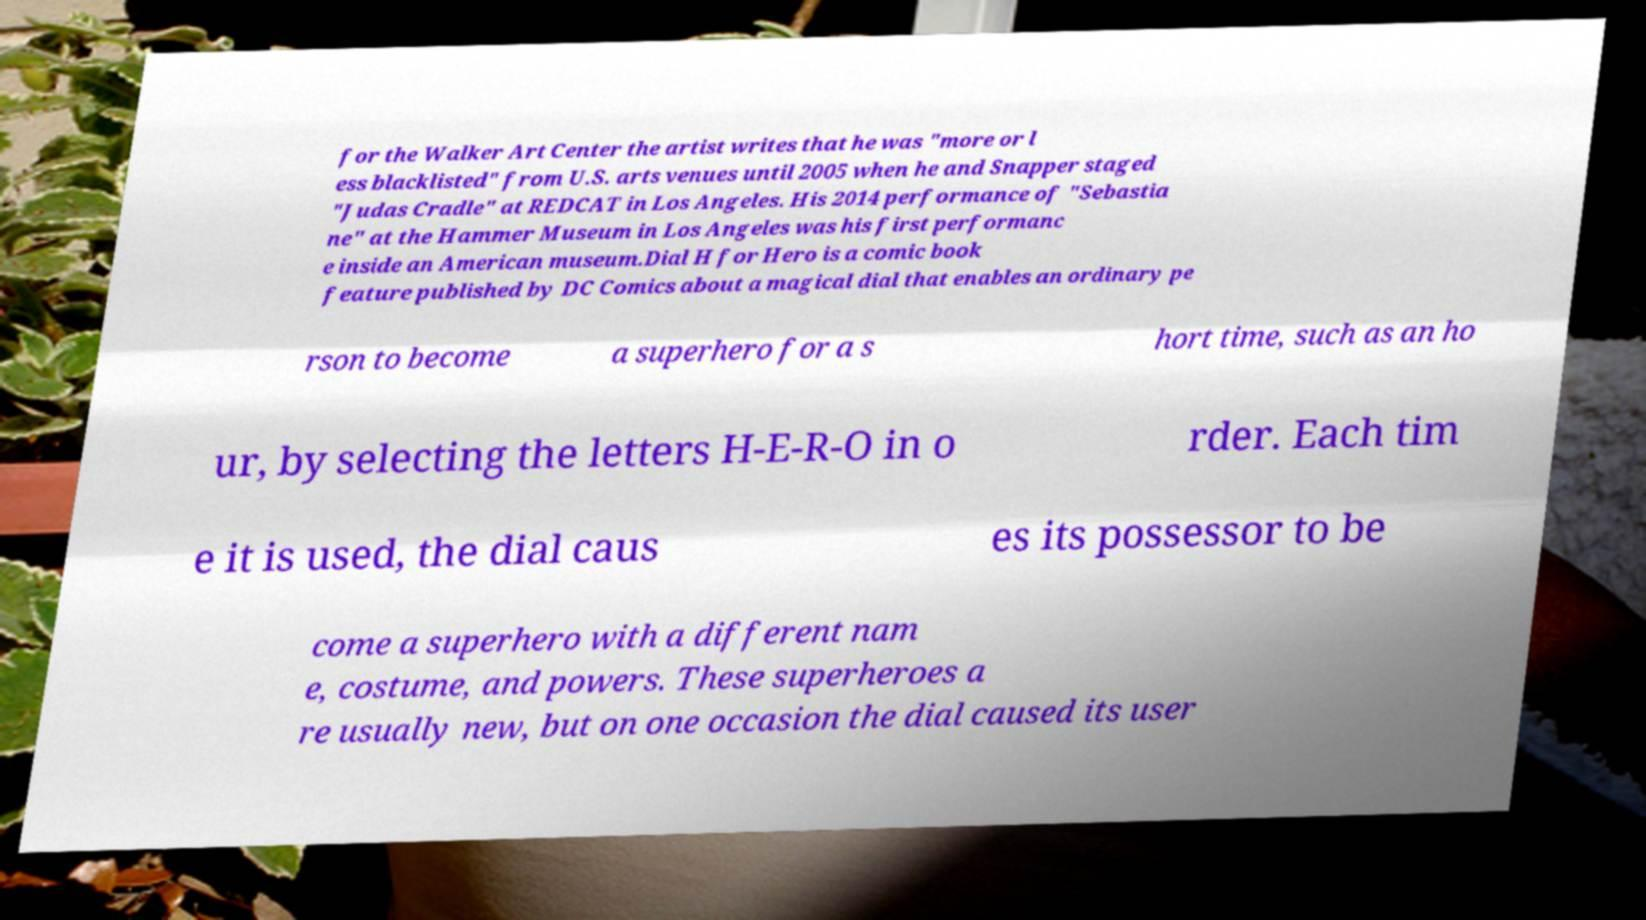There's text embedded in this image that I need extracted. Can you transcribe it verbatim? for the Walker Art Center the artist writes that he was "more or l ess blacklisted" from U.S. arts venues until 2005 when he and Snapper staged "Judas Cradle" at REDCAT in Los Angeles. His 2014 performance of "Sebastia ne" at the Hammer Museum in Los Angeles was his first performanc e inside an American museum.Dial H for Hero is a comic book feature published by DC Comics about a magical dial that enables an ordinary pe rson to become a superhero for a s hort time, such as an ho ur, by selecting the letters H-E-R-O in o rder. Each tim e it is used, the dial caus es its possessor to be come a superhero with a different nam e, costume, and powers. These superheroes a re usually new, but on one occasion the dial caused its user 